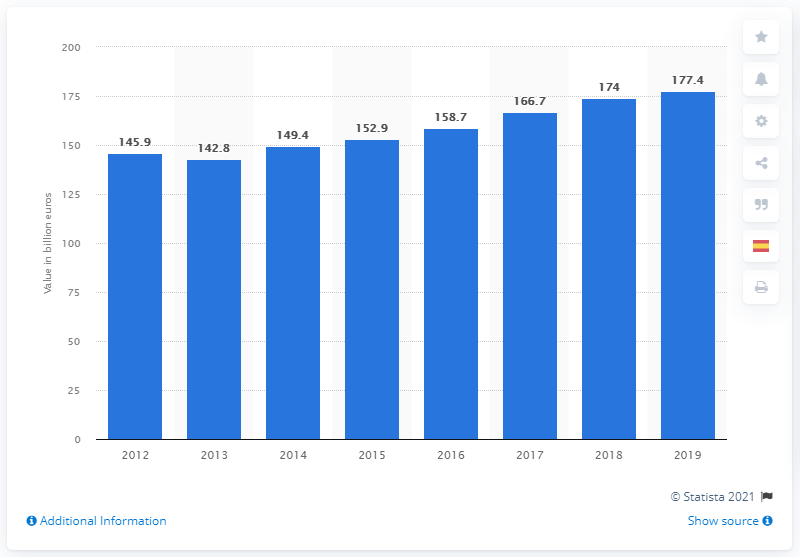What was Spain's GDP contribution in 2019? According to the displayed bar chart, Spain's GDP contribution in 2019 was €1.774 trillion. The chart shows a consistent growth in Spain's GDP over the years, with 2019 marking the highest value within this dataset. 